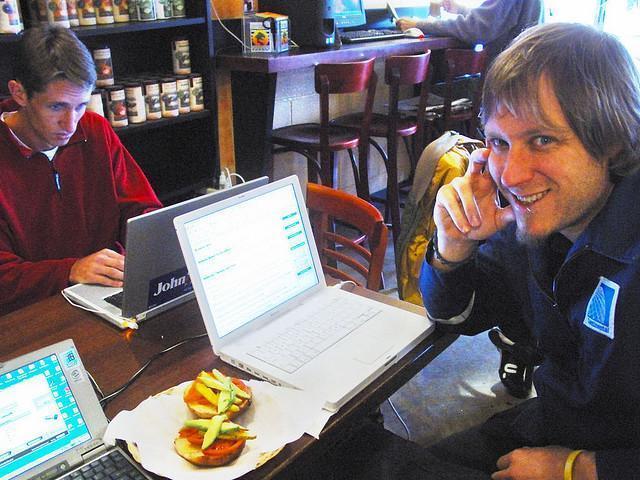How many eyebrows does the man have?
Give a very brief answer. 2. How many chairs are in the picture?
Give a very brief answer. 4. How many laptops are there?
Give a very brief answer. 3. How many people are visible?
Give a very brief answer. 3. How many blue cars are setting on the road?
Give a very brief answer. 0. 